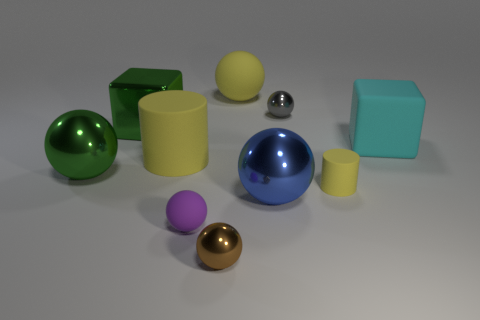Do the large matte ball and the small rubber cylinder have the same color?
Offer a very short reply. Yes. What number of things are either green objects behind the large cyan matte object or green objects that are in front of the large cyan thing?
Ensure brevity in your answer.  2. There is a blue object that is the same shape as the small brown metallic object; what is its material?
Keep it short and to the point. Metal. How many shiny objects are large cyan things or yellow things?
Make the answer very short. 0. There is a big cyan object that is made of the same material as the tiny purple object; what shape is it?
Your answer should be very brief. Cube. What number of tiny shiny objects have the same shape as the purple rubber thing?
Give a very brief answer. 2. Is the shape of the small matte object behind the large blue thing the same as the thing that is on the left side of the shiny block?
Your answer should be very brief. No. What number of things are either brown shiny spheres or matte objects that are to the right of the tiny gray metallic sphere?
Provide a succinct answer. 3. What shape is the metallic thing that is the same color as the metallic cube?
Your answer should be very brief. Sphere. What number of matte balls have the same size as the cyan cube?
Make the answer very short. 1. 